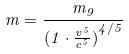<formula> <loc_0><loc_0><loc_500><loc_500>m = \frac { m _ { 9 } } { ( { 1 \cdot \frac { v ^ { 5 } } { c ^ { 5 } } ) } ^ { 4 / 5 } }</formula> 